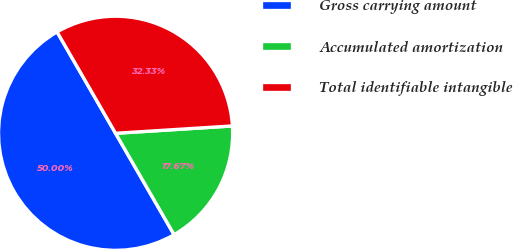Convert chart to OTSL. <chart><loc_0><loc_0><loc_500><loc_500><pie_chart><fcel>Gross carrying amount<fcel>Accumulated amortization<fcel>Total identifiable intangible<nl><fcel>50.0%<fcel>17.67%<fcel>32.33%<nl></chart> 